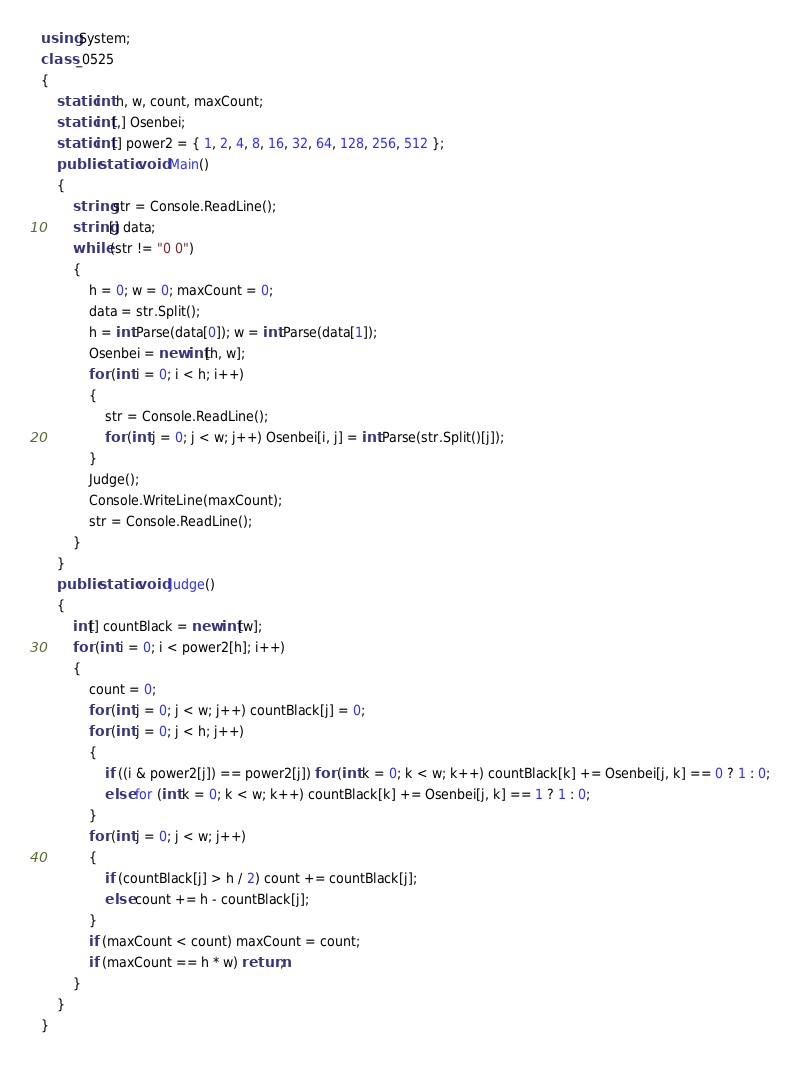<code> <loc_0><loc_0><loc_500><loc_500><_C#_>using System;
class _0525
{
    static int h, w, count, maxCount;
    static int[,] Osenbei;
    static int[] power2 = { 1, 2, 4, 8, 16, 32, 64, 128, 256, 512 };
    public static void Main()
    {
        string str = Console.ReadLine();
        string[] data;
        while (str != "0 0")
        {
            h = 0; w = 0; maxCount = 0;
            data = str.Split();
            h = int.Parse(data[0]); w = int.Parse(data[1]);
            Osenbei = new int[h, w];
            for (int i = 0; i < h; i++)
            {
                str = Console.ReadLine();
                for (int j = 0; j < w; j++) Osenbei[i, j] = int.Parse(str.Split()[j]);
            }
            Judge();
            Console.WriteLine(maxCount);
            str = Console.ReadLine();
        }
    }
    public static void Judge()
    {
        int[] countBlack = new int[w];
        for (int i = 0; i < power2[h]; i++)
        {
            count = 0;
            for (int j = 0; j < w; j++) countBlack[j] = 0;
            for (int j = 0; j < h; j++)
            {
                if ((i & power2[j]) == power2[j]) for (int k = 0; k < w; k++) countBlack[k] += Osenbei[j, k] == 0 ? 1 : 0;
                else for (int k = 0; k < w; k++) countBlack[k] += Osenbei[j, k] == 1 ? 1 : 0;
            }
            for (int j = 0; j < w; j++)
            {
                if (countBlack[j] > h / 2) count += countBlack[j];
                else count += h - countBlack[j];
            }
            if (maxCount < count) maxCount = count;
            if (maxCount == h * w) return;
        }
    }
}</code> 